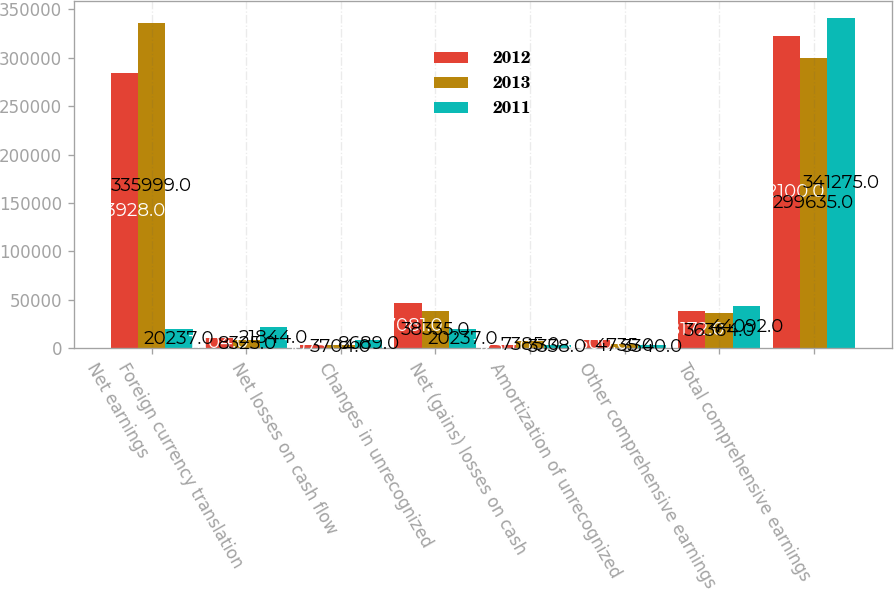<chart> <loc_0><loc_0><loc_500><loc_500><stacked_bar_chart><ecel><fcel>Net earnings<fcel>Foreign currency translation<fcel>Net losses on cash flow<fcel>Changes in unrecognized<fcel>Net (gains) losses on cash<fcel>Amortization of unrecognized<fcel>Other comprehensive earnings<fcel>Total comprehensive earnings<nl><fcel>2012<fcel>283928<fcel>11104<fcel>3075<fcel>47081<fcel>3230<fcel>8500<fcel>38172<fcel>322100<nl><fcel>2013<fcel>335999<fcel>8325<fcel>3704<fcel>38335<fcel>7385<fcel>4735<fcel>36364<fcel>299635<nl><fcel>2011<fcel>20237<fcel>21844<fcel>8689<fcel>20237<fcel>3338<fcel>3340<fcel>44092<fcel>341275<nl></chart> 